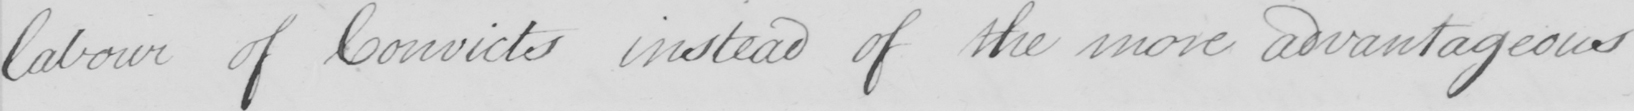Can you tell me what this handwritten text says? labour of Convicts instead of the more advantageous 